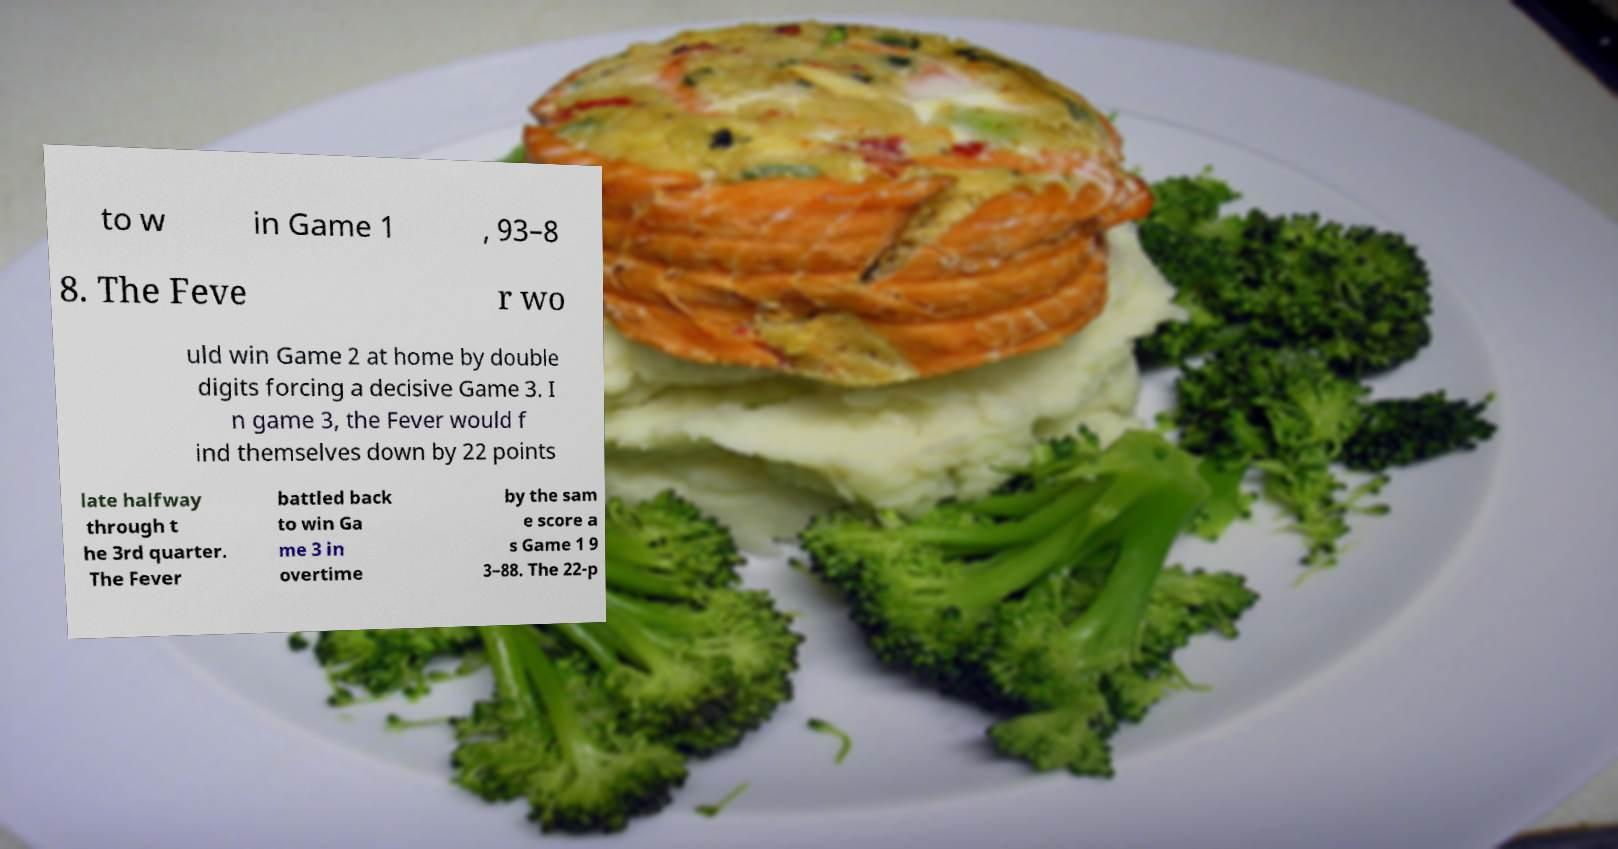There's text embedded in this image that I need extracted. Can you transcribe it verbatim? to w in Game 1 , 93–8 8. The Feve r wo uld win Game 2 at home by double digits forcing a decisive Game 3. I n game 3, the Fever would f ind themselves down by 22 points late halfway through t he 3rd quarter. The Fever battled back to win Ga me 3 in overtime by the sam e score a s Game 1 9 3–88. The 22-p 